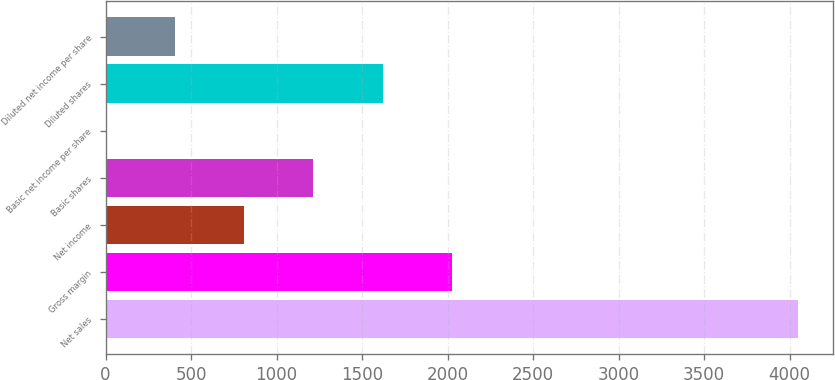Convert chart to OTSL. <chart><loc_0><loc_0><loc_500><loc_500><bar_chart><fcel>Net sales<fcel>Gross margin<fcel>Net income<fcel>Basic shares<fcel>Basic net income per share<fcel>Diluted shares<fcel>Diluted net income per share<nl><fcel>4051<fcel>2025.83<fcel>810.71<fcel>1215.75<fcel>0.63<fcel>1620.79<fcel>405.67<nl></chart> 